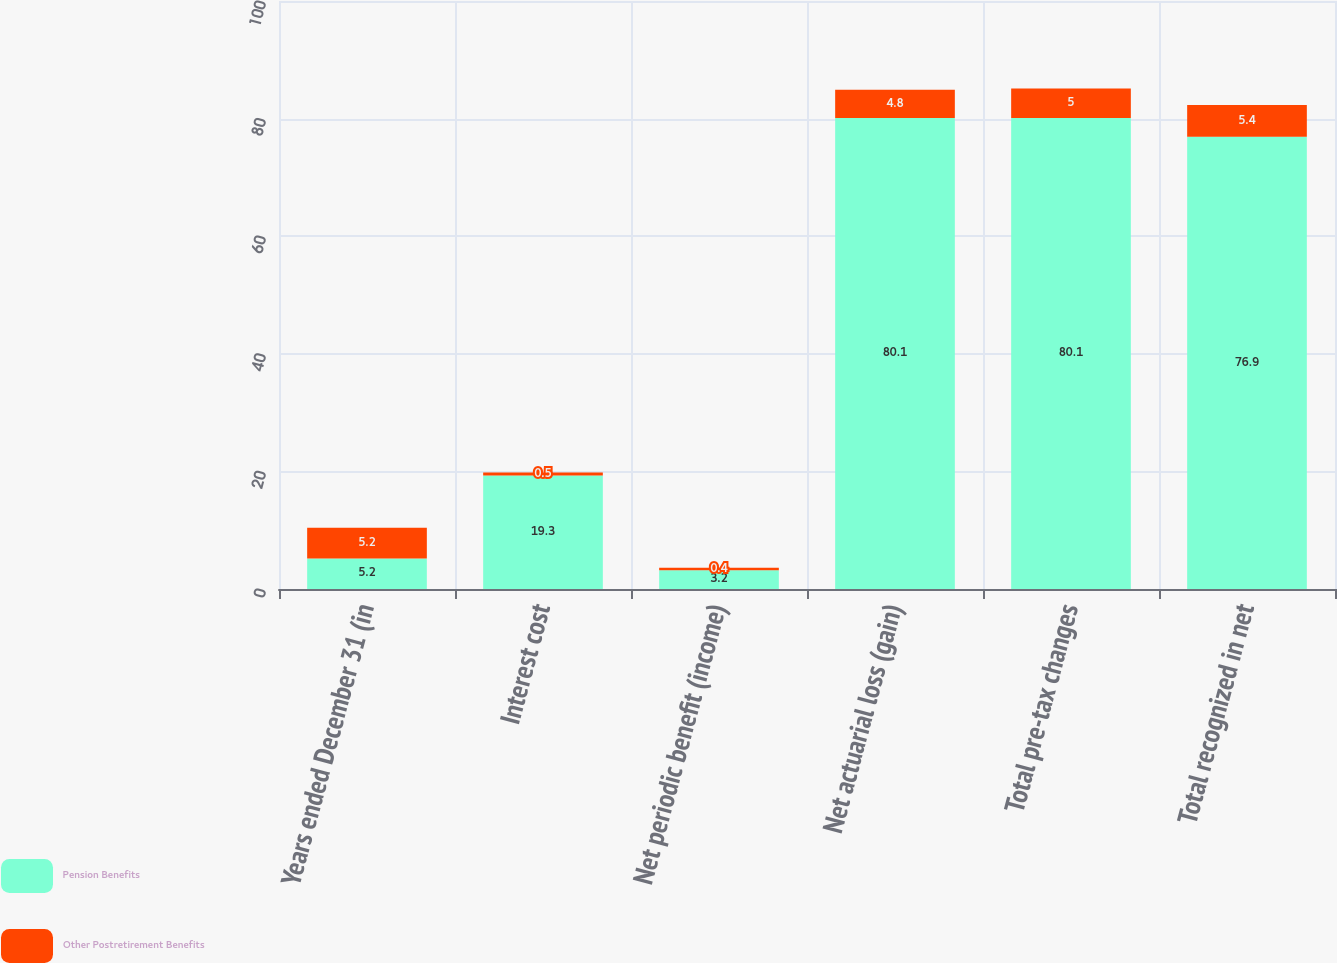<chart> <loc_0><loc_0><loc_500><loc_500><stacked_bar_chart><ecel><fcel>Years ended December 31 (in<fcel>Interest cost<fcel>Net periodic benefit (income)<fcel>Net actuarial loss (gain)<fcel>Total pre-tax changes<fcel>Total recognized in net<nl><fcel>Pension Benefits<fcel>5.2<fcel>19.3<fcel>3.2<fcel>80.1<fcel>80.1<fcel>76.9<nl><fcel>Other Postretirement Benefits<fcel>5.2<fcel>0.5<fcel>0.4<fcel>4.8<fcel>5<fcel>5.4<nl></chart> 